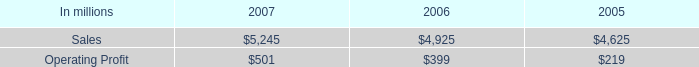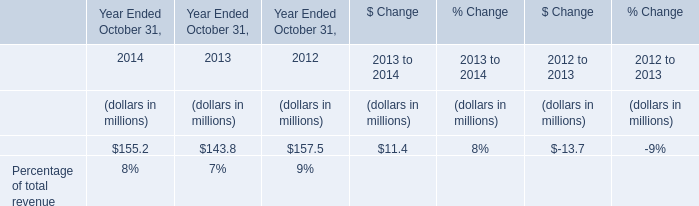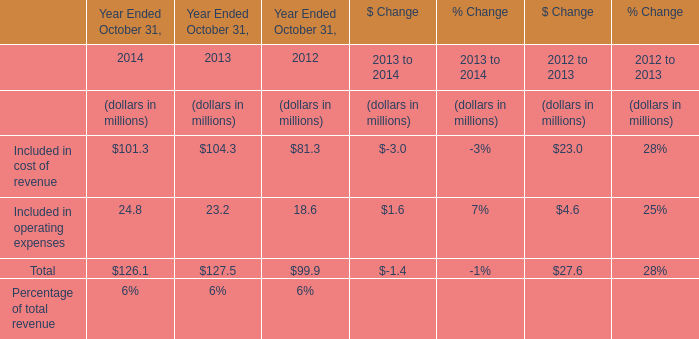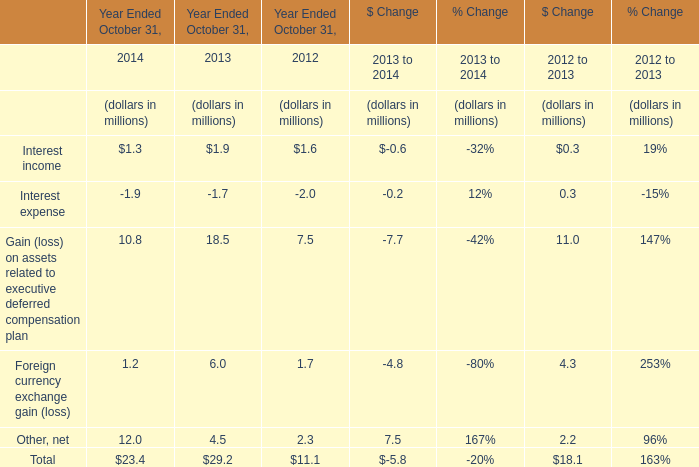In which section is Interest income smaller than Gain (loss) on assets related to executive deferred compensation plan? 
Answer: Year Ended October 31,. 